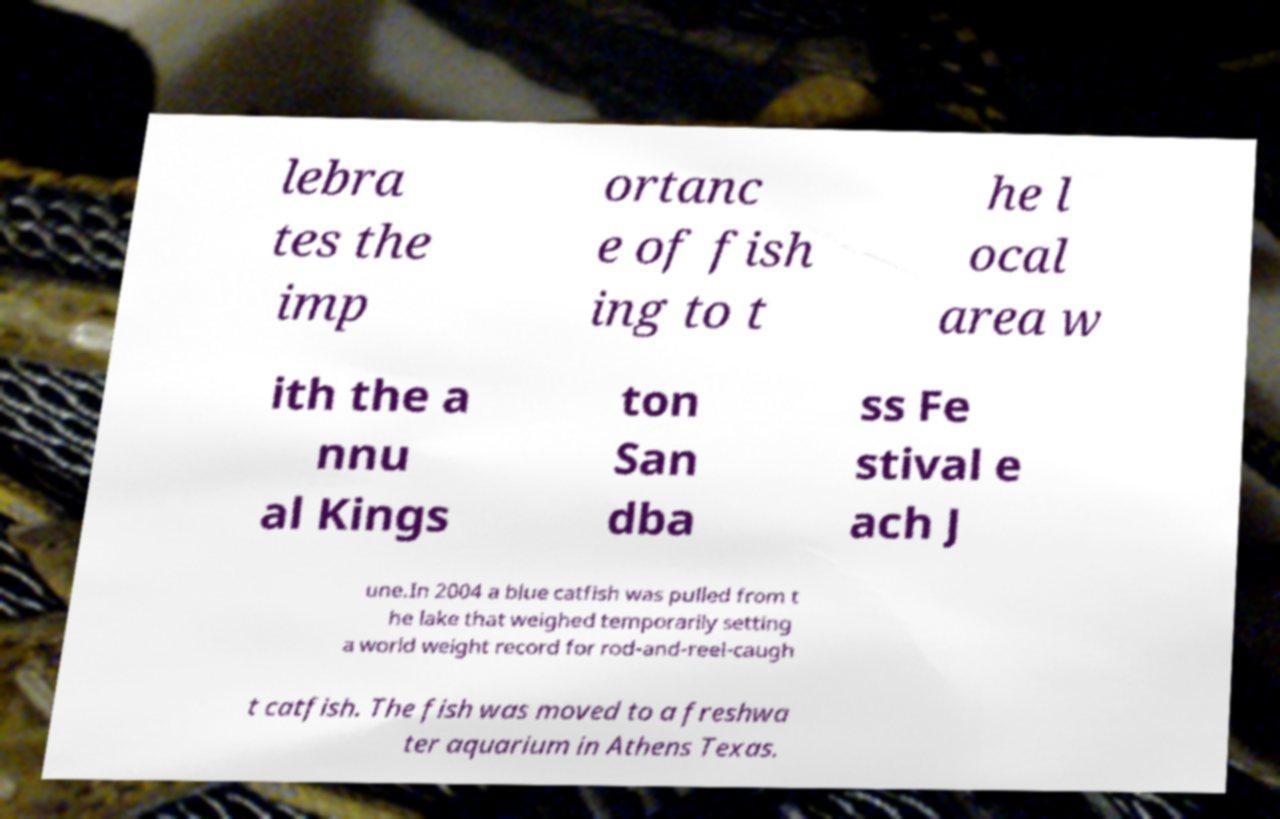Please read and relay the text visible in this image. What does it say? lebra tes the imp ortanc e of fish ing to t he l ocal area w ith the a nnu al Kings ton San dba ss Fe stival e ach J une.In 2004 a blue catfish was pulled from t he lake that weighed temporarily setting a world weight record for rod-and-reel-caugh t catfish. The fish was moved to a freshwa ter aquarium in Athens Texas. 